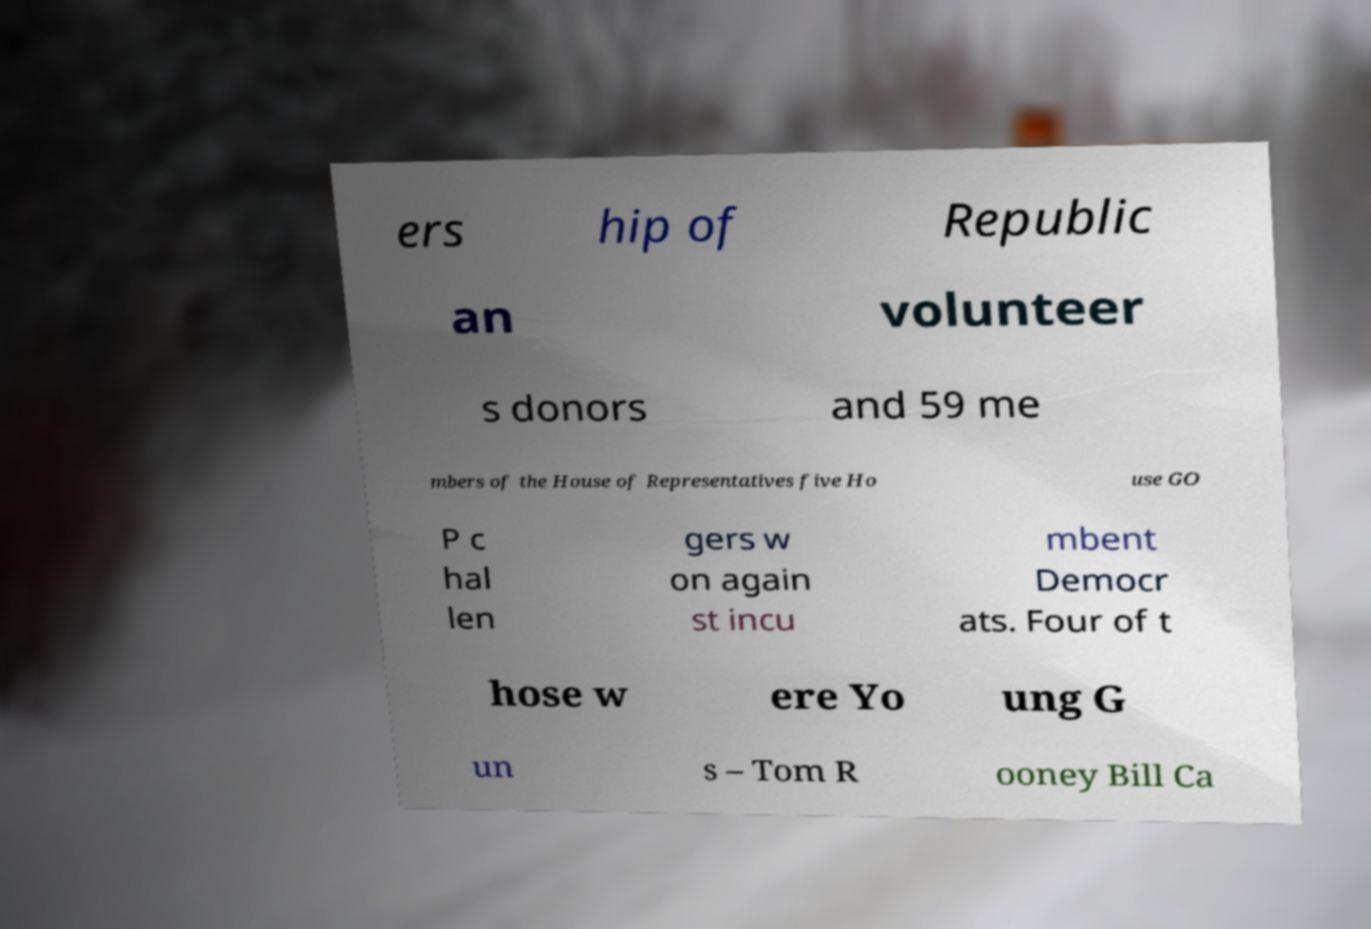There's text embedded in this image that I need extracted. Can you transcribe it verbatim? ers hip of Republic an volunteer s donors and 59 me mbers of the House of Representatives five Ho use GO P c hal len gers w on again st incu mbent Democr ats. Four of t hose w ere Yo ung G un s – Tom R ooney Bill Ca 